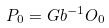Convert formula to latex. <formula><loc_0><loc_0><loc_500><loc_500>P _ { 0 } = G b ^ { - 1 } O _ { 0 }</formula> 